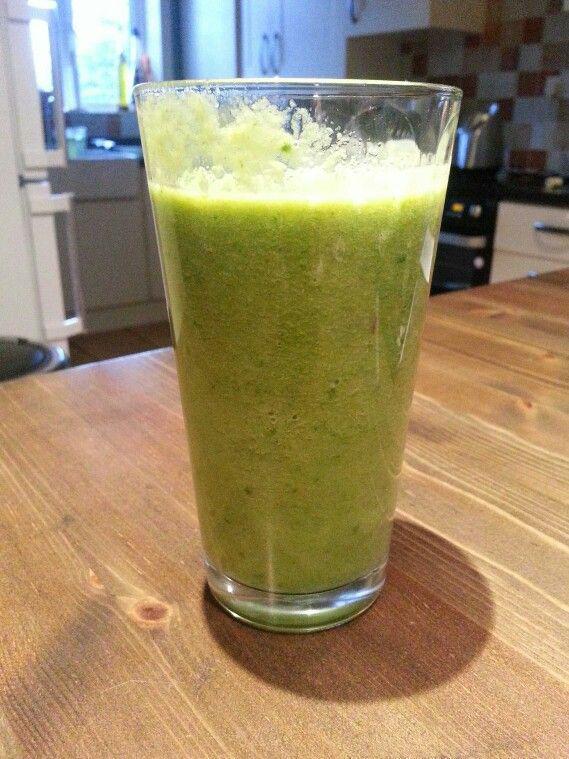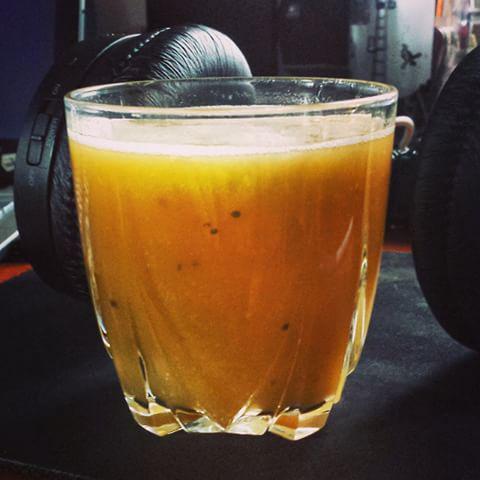The first image is the image on the left, the second image is the image on the right. Considering the images on both sides, is "Each image includes one garnished glass of creamy beverage but no straws, and one of the glasses pictured has a leafy green garnish." valid? Answer yes or no. No. The first image is the image on the left, the second image is the image on the right. For the images shown, is this caption "There is green juice in one of the images." true? Answer yes or no. Yes. 